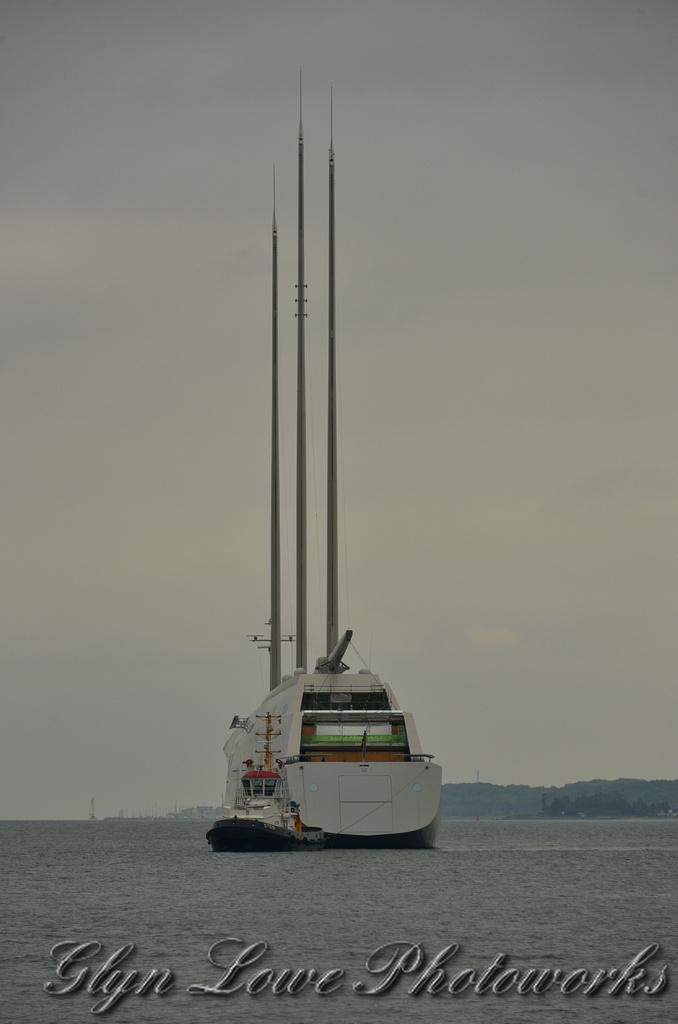What is the main subject in the center of the image? There is a ship in the center of the image. Where is the ship located? The ship is on the water. What can be seen in the background of the image? There are hills and the sky visible in the background of the image. Is there any text present in the image? Yes, there is text at the bottom of the image. How many cakes are floating in the water next to the ship? There are no cakes present in the image; the ship is on the water, but there are no cakes visible. 